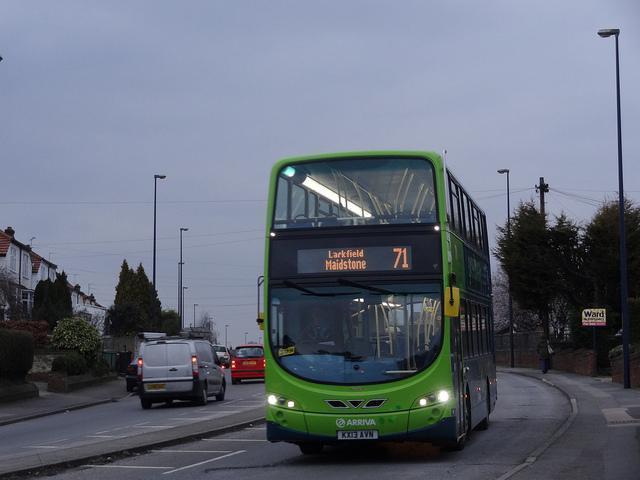How many blue trains can you see?
Give a very brief answer. 0. 